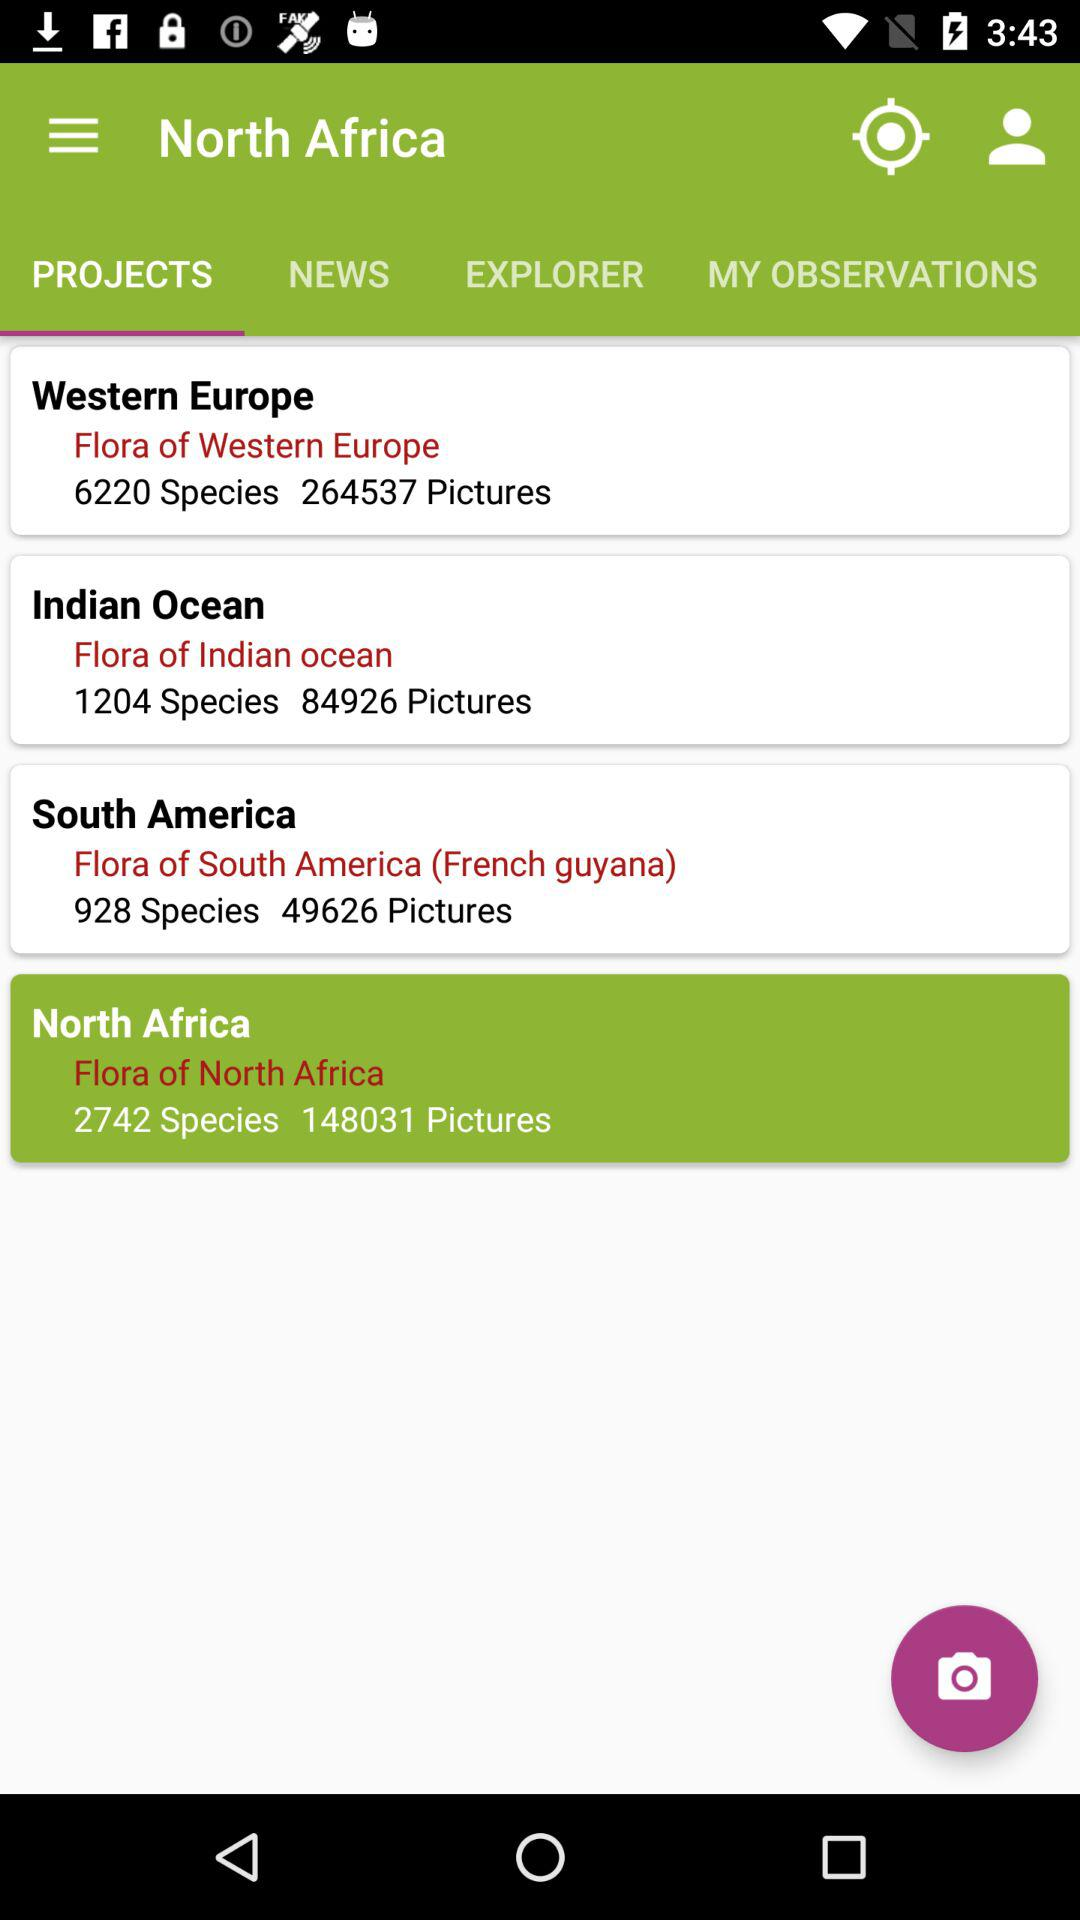How many pictures are there of flora in the Indian Ocean?
Answer the question using a single word or phrase. 84926 